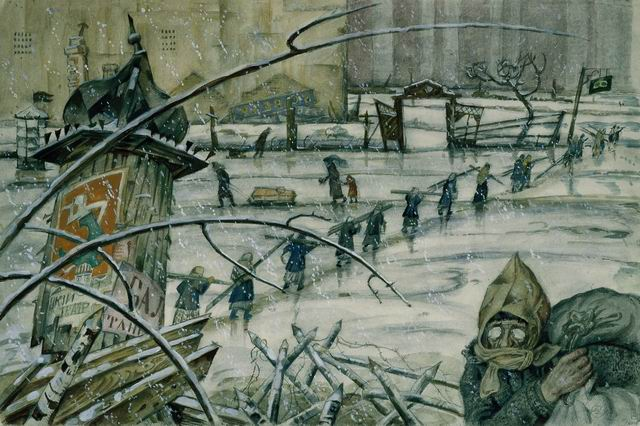If this image were a portal to another world, what would that world be like? Stepping through this image as a portal, one would find themselves in a parallel dimension where endless winter reigns supreme. In this world, survival hinges on adapting to relentless cold and scarce resources. The clouds hang perpetually heavy, and the air is thick with the silent songs of war-torn relics. Cities, once thriving, are now ghost towns where the faint echoes of past lives linger. However, amidst the ice and ruin, small refuges of warmth and light exist. These pockets are inhabited by resilient communities that have evolved to withstand the freezing temperatures, developing unique ways of generating heat, cultivated ice-resistant crops, and even downy fur for additional warmth. Daily life involves foraging for supplies, maintaining intricate networks of underground tunnels, and sharing knowledge about ancient technologies left behind by civilizations past. Despite the harsh environment, these communities are bound by strong ties of cooperation and an unyielding spirit of survival. 